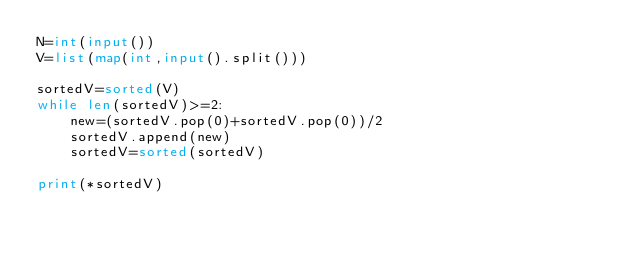<code> <loc_0><loc_0><loc_500><loc_500><_Python_>N=int(input())
V=list(map(int,input().split()))

sortedV=sorted(V)
while len(sortedV)>=2:
    new=(sortedV.pop(0)+sortedV.pop(0))/2
    sortedV.append(new)
    sortedV=sorted(sortedV)

print(*sortedV)</code> 